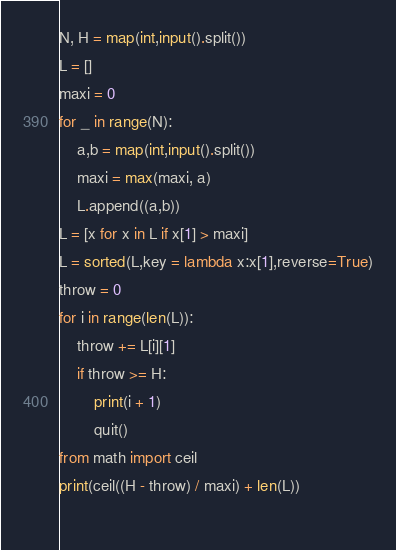<code> <loc_0><loc_0><loc_500><loc_500><_Python_>N, H = map(int,input().split())
L = []
maxi = 0
for _ in range(N):
    a,b = map(int,input().split())
    maxi = max(maxi, a)
    L.append((a,b))
L = [x for x in L if x[1] > maxi]
L = sorted(L,key = lambda x:x[1],reverse=True)
throw = 0
for i in range(len(L)):
    throw += L[i][1]
    if throw >= H:
        print(i + 1)
        quit()
from math import ceil
print(ceil((H - throw) / maxi) + len(L))
    
</code> 